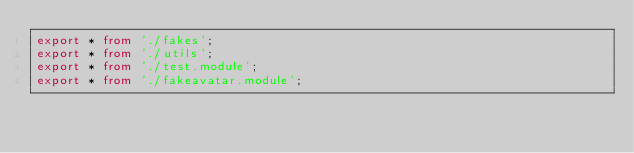Convert code to text. <code><loc_0><loc_0><loc_500><loc_500><_TypeScript_>export * from './fakes';
export * from './utils';
export * from './test.module';
export * from './fakeavatar.module';
</code> 